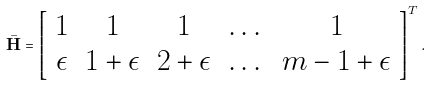<formula> <loc_0><loc_0><loc_500><loc_500>\bar { \mathbf H } = \left [ \begin{array} { c c c c c } 1 & 1 & 1 & \dots & 1 \\ \epsilon & 1 + \epsilon & 2 + \epsilon & \dots & m - 1 + \epsilon \end{array} \right ] ^ { T } .</formula> 